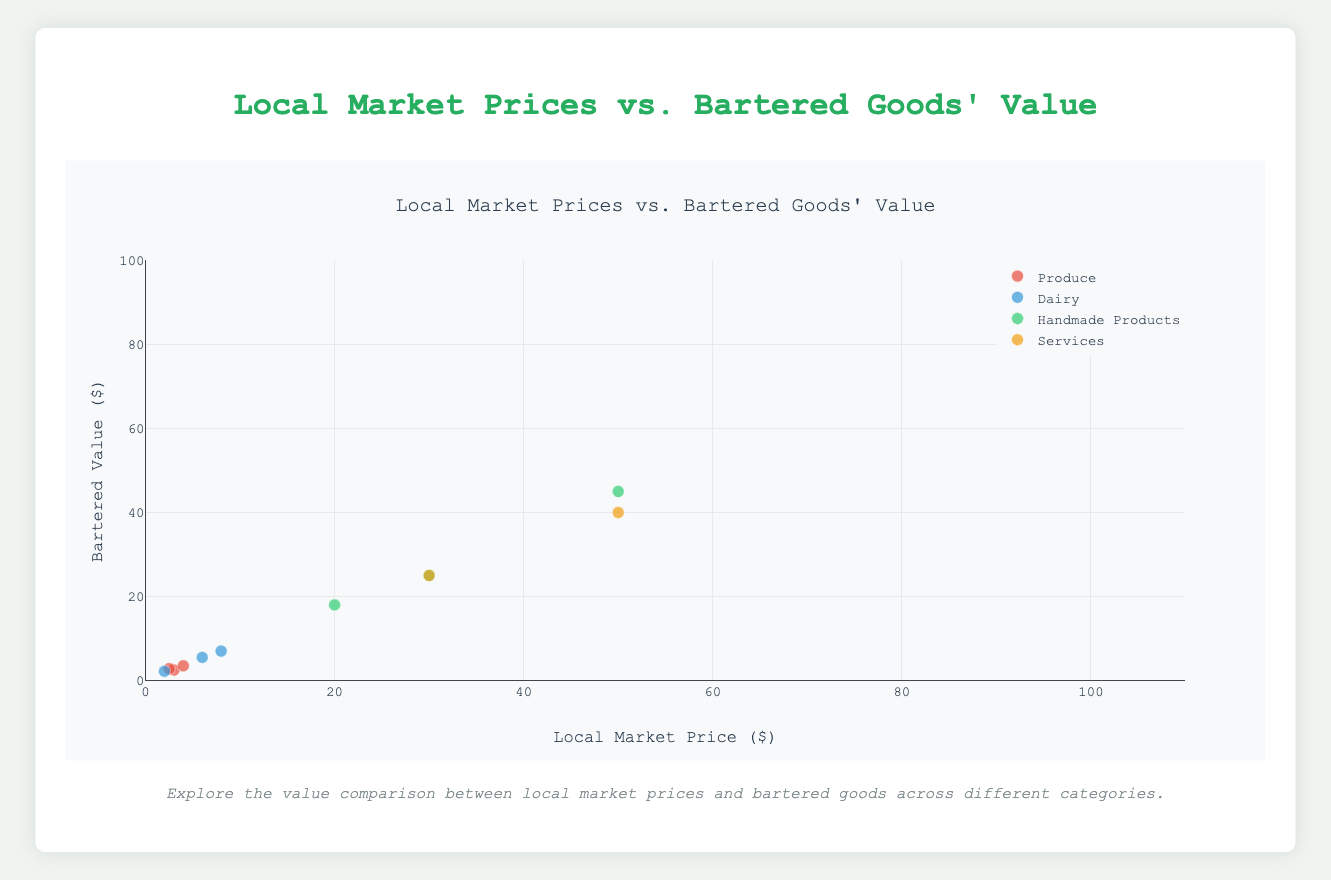What is the title of the figure? The title is prominently displayed at the top of the figure.
Answer: Local Market Prices vs. Bartered Goods' Value What does the x-axis represent? The label of the x-axis indicates the values it represents.
Answer: Local Market Price ($) How many product categories are being compared? The legend on the right side of the chart lists all the categories.
Answer: Four Which product in the 'Services' category has the highest local market price? In the 'Services' category group, identify the highest x-value.
Answer: Gardening Services (per hour) Which data point in the 'Produce' category shows a higher bartered value than the local market price? Look at the y-values and x-values for the 'Produce' category; one point has a higher y-value than x-value.
Answer: Fresh Cucumbers What is the local market price for 'Artisanal Cheese'? From the 'Dairy' group, locate the data point labeled 'Artisanal Cheese.' The x-axis provides the price.
Answer: $8 Compare the bartered values for 'Handmade Soap' and 'Handcrafted Candles.' Which one is higher? Examine the y-values of 'Handmade Soap' and 'Handcrafted Candles' in the 'Handmade Products' category.
Answer: Handcrafted Candles What is the average local market price for items in the 'Produce' category? Sum the local market prices of all 'Produce' items and divide by the number of items. (3 + 2.5 + 4) / 3 = 3.17
Answer: $3.17 Is the bartered value for 'Farm Fresh Eggs' higher or lower than its local market price? Compare the y-value and x-value for 'Farm Fresh Eggs' in the 'Dairy' category.
Answer: Higher 